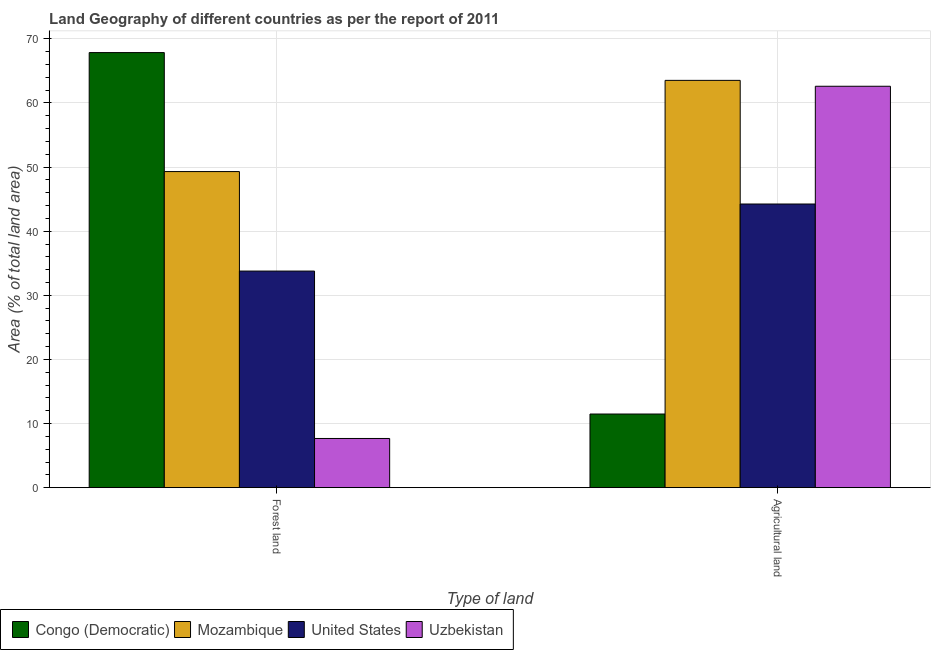Are the number of bars per tick equal to the number of legend labels?
Keep it short and to the point. Yes. What is the label of the 1st group of bars from the left?
Ensure brevity in your answer.  Forest land. What is the percentage of land area under agriculture in United States?
Ensure brevity in your answer.  44.24. Across all countries, what is the maximum percentage of land area under agriculture?
Your response must be concise. 63.52. Across all countries, what is the minimum percentage of land area under forests?
Keep it short and to the point. 7.67. In which country was the percentage of land area under forests maximum?
Your answer should be compact. Congo (Democratic). In which country was the percentage of land area under forests minimum?
Your response must be concise. Uzbekistan. What is the total percentage of land area under agriculture in the graph?
Your answer should be compact. 181.84. What is the difference between the percentage of land area under forests in Mozambique and that in United States?
Your response must be concise. 15.52. What is the difference between the percentage of land area under agriculture in Mozambique and the percentage of land area under forests in United States?
Your response must be concise. 29.74. What is the average percentage of land area under agriculture per country?
Offer a terse response. 45.46. What is the difference between the percentage of land area under agriculture and percentage of land area under forests in United States?
Offer a terse response. 10.46. What is the ratio of the percentage of land area under forests in Uzbekistan to that in United States?
Your answer should be very brief. 0.23. Is the percentage of land area under forests in Mozambique less than that in Uzbekistan?
Offer a terse response. No. In how many countries, is the percentage of land area under forests greater than the average percentage of land area under forests taken over all countries?
Offer a very short reply. 2. What does the 3rd bar from the left in Agricultural land represents?
Keep it short and to the point. United States. What does the 4th bar from the right in Agricultural land represents?
Make the answer very short. Congo (Democratic). How many bars are there?
Provide a succinct answer. 8. Are all the bars in the graph horizontal?
Provide a short and direct response. No. Does the graph contain grids?
Provide a succinct answer. Yes. Where does the legend appear in the graph?
Provide a short and direct response. Bottom left. How many legend labels are there?
Offer a very short reply. 4. What is the title of the graph?
Your answer should be very brief. Land Geography of different countries as per the report of 2011. Does "Sint Maarten (Dutch part)" appear as one of the legend labels in the graph?
Provide a short and direct response. No. What is the label or title of the X-axis?
Provide a short and direct response. Type of land. What is the label or title of the Y-axis?
Provide a succinct answer. Area (% of total land area). What is the Area (% of total land area) in Congo (Democratic) in Forest land?
Keep it short and to the point. 67.85. What is the Area (% of total land area) in Mozambique in Forest land?
Provide a short and direct response. 49.3. What is the Area (% of total land area) of United States in Forest land?
Offer a very short reply. 33.78. What is the Area (% of total land area) in Uzbekistan in Forest land?
Make the answer very short. 7.67. What is the Area (% of total land area) of Congo (Democratic) in Agricultural land?
Provide a short and direct response. 11.49. What is the Area (% of total land area) in Mozambique in Agricultural land?
Your response must be concise. 63.52. What is the Area (% of total land area) in United States in Agricultural land?
Keep it short and to the point. 44.24. What is the Area (% of total land area) of Uzbekistan in Agricultural land?
Your answer should be compact. 62.6. Across all Type of land, what is the maximum Area (% of total land area) of Congo (Democratic)?
Make the answer very short. 67.85. Across all Type of land, what is the maximum Area (% of total land area) in Mozambique?
Keep it short and to the point. 63.52. Across all Type of land, what is the maximum Area (% of total land area) in United States?
Provide a short and direct response. 44.24. Across all Type of land, what is the maximum Area (% of total land area) of Uzbekistan?
Your answer should be compact. 62.6. Across all Type of land, what is the minimum Area (% of total land area) of Congo (Democratic)?
Give a very brief answer. 11.49. Across all Type of land, what is the minimum Area (% of total land area) of Mozambique?
Provide a short and direct response. 49.3. Across all Type of land, what is the minimum Area (% of total land area) of United States?
Make the answer very short. 33.78. Across all Type of land, what is the minimum Area (% of total land area) in Uzbekistan?
Your answer should be compact. 7.67. What is the total Area (% of total land area) in Congo (Democratic) in the graph?
Give a very brief answer. 79.34. What is the total Area (% of total land area) of Mozambique in the graph?
Give a very brief answer. 112.82. What is the total Area (% of total land area) of United States in the graph?
Offer a very short reply. 78.02. What is the total Area (% of total land area) in Uzbekistan in the graph?
Provide a succinct answer. 70.27. What is the difference between the Area (% of total land area) in Congo (Democratic) in Forest land and that in Agricultural land?
Your response must be concise. 56.37. What is the difference between the Area (% of total land area) of Mozambique in Forest land and that in Agricultural land?
Your response must be concise. -14.22. What is the difference between the Area (% of total land area) of United States in Forest land and that in Agricultural land?
Provide a short and direct response. -10.46. What is the difference between the Area (% of total land area) in Uzbekistan in Forest land and that in Agricultural land?
Provide a short and direct response. -54.93. What is the difference between the Area (% of total land area) of Congo (Democratic) in Forest land and the Area (% of total land area) of Mozambique in Agricultural land?
Provide a succinct answer. 4.33. What is the difference between the Area (% of total land area) of Congo (Democratic) in Forest land and the Area (% of total land area) of United States in Agricultural land?
Make the answer very short. 23.61. What is the difference between the Area (% of total land area) of Congo (Democratic) in Forest land and the Area (% of total land area) of Uzbekistan in Agricultural land?
Offer a very short reply. 5.25. What is the difference between the Area (% of total land area) in Mozambique in Forest land and the Area (% of total land area) in United States in Agricultural land?
Your response must be concise. 5.06. What is the difference between the Area (% of total land area) of Mozambique in Forest land and the Area (% of total land area) of Uzbekistan in Agricultural land?
Provide a succinct answer. -13.3. What is the difference between the Area (% of total land area) in United States in Forest land and the Area (% of total land area) in Uzbekistan in Agricultural land?
Keep it short and to the point. -28.82. What is the average Area (% of total land area) of Congo (Democratic) per Type of land?
Ensure brevity in your answer.  39.67. What is the average Area (% of total land area) of Mozambique per Type of land?
Your answer should be compact. 56.41. What is the average Area (% of total land area) of United States per Type of land?
Provide a succinct answer. 39.01. What is the average Area (% of total land area) in Uzbekistan per Type of land?
Ensure brevity in your answer.  35.14. What is the difference between the Area (% of total land area) of Congo (Democratic) and Area (% of total land area) of Mozambique in Forest land?
Make the answer very short. 18.56. What is the difference between the Area (% of total land area) of Congo (Democratic) and Area (% of total land area) of United States in Forest land?
Offer a terse response. 34.07. What is the difference between the Area (% of total land area) in Congo (Democratic) and Area (% of total land area) in Uzbekistan in Forest land?
Your answer should be very brief. 60.18. What is the difference between the Area (% of total land area) in Mozambique and Area (% of total land area) in United States in Forest land?
Provide a short and direct response. 15.52. What is the difference between the Area (% of total land area) in Mozambique and Area (% of total land area) in Uzbekistan in Forest land?
Provide a succinct answer. 41.62. What is the difference between the Area (% of total land area) in United States and Area (% of total land area) in Uzbekistan in Forest land?
Offer a terse response. 26.11. What is the difference between the Area (% of total land area) of Congo (Democratic) and Area (% of total land area) of Mozambique in Agricultural land?
Your answer should be compact. -52.03. What is the difference between the Area (% of total land area) of Congo (Democratic) and Area (% of total land area) of United States in Agricultural land?
Your response must be concise. -32.75. What is the difference between the Area (% of total land area) of Congo (Democratic) and Area (% of total land area) of Uzbekistan in Agricultural land?
Keep it short and to the point. -51.11. What is the difference between the Area (% of total land area) of Mozambique and Area (% of total land area) of United States in Agricultural land?
Provide a succinct answer. 19.28. What is the difference between the Area (% of total land area) of Mozambique and Area (% of total land area) of Uzbekistan in Agricultural land?
Make the answer very short. 0.92. What is the difference between the Area (% of total land area) of United States and Area (% of total land area) of Uzbekistan in Agricultural land?
Ensure brevity in your answer.  -18.36. What is the ratio of the Area (% of total land area) in Congo (Democratic) in Forest land to that in Agricultural land?
Offer a terse response. 5.91. What is the ratio of the Area (% of total land area) of Mozambique in Forest land to that in Agricultural land?
Ensure brevity in your answer.  0.78. What is the ratio of the Area (% of total land area) in United States in Forest land to that in Agricultural land?
Make the answer very short. 0.76. What is the ratio of the Area (% of total land area) in Uzbekistan in Forest land to that in Agricultural land?
Give a very brief answer. 0.12. What is the difference between the highest and the second highest Area (% of total land area) in Congo (Democratic)?
Provide a short and direct response. 56.37. What is the difference between the highest and the second highest Area (% of total land area) in Mozambique?
Give a very brief answer. 14.22. What is the difference between the highest and the second highest Area (% of total land area) in United States?
Ensure brevity in your answer.  10.46. What is the difference between the highest and the second highest Area (% of total land area) of Uzbekistan?
Make the answer very short. 54.93. What is the difference between the highest and the lowest Area (% of total land area) of Congo (Democratic)?
Keep it short and to the point. 56.37. What is the difference between the highest and the lowest Area (% of total land area) of Mozambique?
Offer a terse response. 14.22. What is the difference between the highest and the lowest Area (% of total land area) in United States?
Make the answer very short. 10.46. What is the difference between the highest and the lowest Area (% of total land area) in Uzbekistan?
Provide a short and direct response. 54.93. 